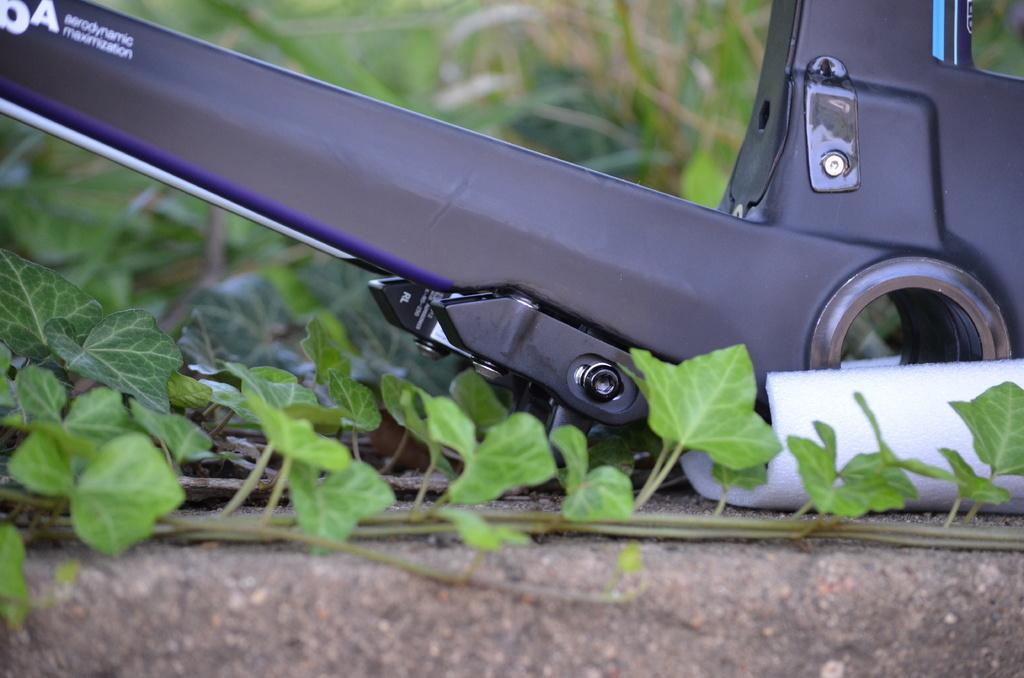What is placed on the land in the image? There is an object placed on the land. What can be seen near the object? There are plants near the object. What type of teaching is being conducted near the object? There is no teaching or any indication of an educational activity in the image. 